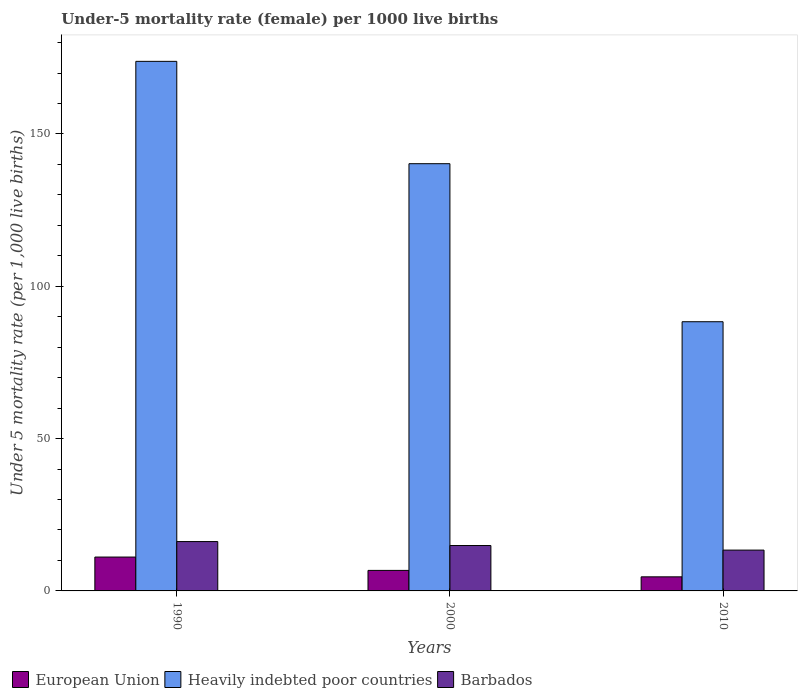How many groups of bars are there?
Your response must be concise. 3. Are the number of bars per tick equal to the number of legend labels?
Provide a short and direct response. Yes. How many bars are there on the 2nd tick from the left?
Offer a very short reply. 3. How many bars are there on the 3rd tick from the right?
Keep it short and to the point. 3. What is the label of the 1st group of bars from the left?
Offer a terse response. 1990. In how many cases, is the number of bars for a given year not equal to the number of legend labels?
Offer a terse response. 0. What is the under-five mortality rate in Barbados in 2000?
Keep it short and to the point. 14.9. Across all years, what is the minimum under-five mortality rate in Heavily indebted poor countries?
Provide a succinct answer. 88.36. In which year was the under-five mortality rate in European Union minimum?
Make the answer very short. 2010. What is the total under-five mortality rate in Heavily indebted poor countries in the graph?
Provide a short and direct response. 402.42. What is the difference between the under-five mortality rate in Barbados in 1990 and that in 2000?
Offer a terse response. 1.3. What is the difference between the under-five mortality rate in European Union in 2000 and the under-five mortality rate in Heavily indebted poor countries in 2010?
Make the answer very short. -81.63. What is the average under-five mortality rate in Heavily indebted poor countries per year?
Your response must be concise. 134.14. In the year 2010, what is the difference between the under-five mortality rate in European Union and under-five mortality rate in Heavily indebted poor countries?
Your response must be concise. -83.74. What is the ratio of the under-five mortality rate in European Union in 1990 to that in 2010?
Provide a short and direct response. 2.4. Is the under-five mortality rate in European Union in 2000 less than that in 2010?
Make the answer very short. No. Is the difference between the under-five mortality rate in European Union in 2000 and 2010 greater than the difference between the under-five mortality rate in Heavily indebted poor countries in 2000 and 2010?
Offer a terse response. No. What is the difference between the highest and the second highest under-five mortality rate in Barbados?
Ensure brevity in your answer.  1.3. What is the difference between the highest and the lowest under-five mortality rate in European Union?
Give a very brief answer. 6.49. Is the sum of the under-five mortality rate in European Union in 2000 and 2010 greater than the maximum under-five mortality rate in Barbados across all years?
Keep it short and to the point. No. What does the 2nd bar from the right in 2000 represents?
Ensure brevity in your answer.  Heavily indebted poor countries. Is it the case that in every year, the sum of the under-five mortality rate in Heavily indebted poor countries and under-five mortality rate in European Union is greater than the under-five mortality rate in Barbados?
Provide a succinct answer. Yes. What is the difference between two consecutive major ticks on the Y-axis?
Provide a succinct answer. 50. What is the title of the graph?
Your answer should be compact. Under-5 mortality rate (female) per 1000 live births. Does "Belize" appear as one of the legend labels in the graph?
Make the answer very short. No. What is the label or title of the Y-axis?
Offer a terse response. Under 5 mortality rate (per 1,0 live births). What is the Under 5 mortality rate (per 1,000 live births) in European Union in 1990?
Make the answer very short. 11.12. What is the Under 5 mortality rate (per 1,000 live births) of Heavily indebted poor countries in 1990?
Give a very brief answer. 173.83. What is the Under 5 mortality rate (per 1,000 live births) of Barbados in 1990?
Make the answer very short. 16.2. What is the Under 5 mortality rate (per 1,000 live births) of European Union in 2000?
Your response must be concise. 6.73. What is the Under 5 mortality rate (per 1,000 live births) of Heavily indebted poor countries in 2000?
Your response must be concise. 140.23. What is the Under 5 mortality rate (per 1,000 live births) in European Union in 2010?
Provide a short and direct response. 4.62. What is the Under 5 mortality rate (per 1,000 live births) of Heavily indebted poor countries in 2010?
Your answer should be compact. 88.36. Across all years, what is the maximum Under 5 mortality rate (per 1,000 live births) of European Union?
Your answer should be compact. 11.12. Across all years, what is the maximum Under 5 mortality rate (per 1,000 live births) of Heavily indebted poor countries?
Your answer should be very brief. 173.83. Across all years, what is the minimum Under 5 mortality rate (per 1,000 live births) of European Union?
Ensure brevity in your answer.  4.62. Across all years, what is the minimum Under 5 mortality rate (per 1,000 live births) in Heavily indebted poor countries?
Offer a terse response. 88.36. Across all years, what is the minimum Under 5 mortality rate (per 1,000 live births) of Barbados?
Your response must be concise. 13.4. What is the total Under 5 mortality rate (per 1,000 live births) in European Union in the graph?
Make the answer very short. 22.48. What is the total Under 5 mortality rate (per 1,000 live births) of Heavily indebted poor countries in the graph?
Your answer should be very brief. 402.42. What is the total Under 5 mortality rate (per 1,000 live births) in Barbados in the graph?
Ensure brevity in your answer.  44.5. What is the difference between the Under 5 mortality rate (per 1,000 live births) in European Union in 1990 and that in 2000?
Ensure brevity in your answer.  4.38. What is the difference between the Under 5 mortality rate (per 1,000 live births) in Heavily indebted poor countries in 1990 and that in 2000?
Offer a terse response. 33.59. What is the difference between the Under 5 mortality rate (per 1,000 live births) of European Union in 1990 and that in 2010?
Ensure brevity in your answer.  6.49. What is the difference between the Under 5 mortality rate (per 1,000 live births) of Heavily indebted poor countries in 1990 and that in 2010?
Provide a short and direct response. 85.47. What is the difference between the Under 5 mortality rate (per 1,000 live births) of Barbados in 1990 and that in 2010?
Offer a very short reply. 2.8. What is the difference between the Under 5 mortality rate (per 1,000 live births) of European Union in 2000 and that in 2010?
Ensure brevity in your answer.  2.11. What is the difference between the Under 5 mortality rate (per 1,000 live births) of Heavily indebted poor countries in 2000 and that in 2010?
Make the answer very short. 51.87. What is the difference between the Under 5 mortality rate (per 1,000 live births) of European Union in 1990 and the Under 5 mortality rate (per 1,000 live births) of Heavily indebted poor countries in 2000?
Ensure brevity in your answer.  -129.12. What is the difference between the Under 5 mortality rate (per 1,000 live births) of European Union in 1990 and the Under 5 mortality rate (per 1,000 live births) of Barbados in 2000?
Your response must be concise. -3.78. What is the difference between the Under 5 mortality rate (per 1,000 live births) of Heavily indebted poor countries in 1990 and the Under 5 mortality rate (per 1,000 live births) of Barbados in 2000?
Make the answer very short. 158.93. What is the difference between the Under 5 mortality rate (per 1,000 live births) of European Union in 1990 and the Under 5 mortality rate (per 1,000 live births) of Heavily indebted poor countries in 2010?
Ensure brevity in your answer.  -77.24. What is the difference between the Under 5 mortality rate (per 1,000 live births) in European Union in 1990 and the Under 5 mortality rate (per 1,000 live births) in Barbados in 2010?
Make the answer very short. -2.28. What is the difference between the Under 5 mortality rate (per 1,000 live births) in Heavily indebted poor countries in 1990 and the Under 5 mortality rate (per 1,000 live births) in Barbados in 2010?
Provide a succinct answer. 160.43. What is the difference between the Under 5 mortality rate (per 1,000 live births) in European Union in 2000 and the Under 5 mortality rate (per 1,000 live births) in Heavily indebted poor countries in 2010?
Give a very brief answer. -81.63. What is the difference between the Under 5 mortality rate (per 1,000 live births) in European Union in 2000 and the Under 5 mortality rate (per 1,000 live births) in Barbados in 2010?
Keep it short and to the point. -6.67. What is the difference between the Under 5 mortality rate (per 1,000 live births) of Heavily indebted poor countries in 2000 and the Under 5 mortality rate (per 1,000 live births) of Barbados in 2010?
Keep it short and to the point. 126.83. What is the average Under 5 mortality rate (per 1,000 live births) in European Union per year?
Provide a succinct answer. 7.49. What is the average Under 5 mortality rate (per 1,000 live births) of Heavily indebted poor countries per year?
Provide a short and direct response. 134.14. What is the average Under 5 mortality rate (per 1,000 live births) of Barbados per year?
Keep it short and to the point. 14.83. In the year 1990, what is the difference between the Under 5 mortality rate (per 1,000 live births) in European Union and Under 5 mortality rate (per 1,000 live births) in Heavily indebted poor countries?
Your response must be concise. -162.71. In the year 1990, what is the difference between the Under 5 mortality rate (per 1,000 live births) in European Union and Under 5 mortality rate (per 1,000 live births) in Barbados?
Offer a terse response. -5.08. In the year 1990, what is the difference between the Under 5 mortality rate (per 1,000 live births) of Heavily indebted poor countries and Under 5 mortality rate (per 1,000 live births) of Barbados?
Offer a very short reply. 157.63. In the year 2000, what is the difference between the Under 5 mortality rate (per 1,000 live births) of European Union and Under 5 mortality rate (per 1,000 live births) of Heavily indebted poor countries?
Your answer should be very brief. -133.5. In the year 2000, what is the difference between the Under 5 mortality rate (per 1,000 live births) in European Union and Under 5 mortality rate (per 1,000 live births) in Barbados?
Keep it short and to the point. -8.17. In the year 2000, what is the difference between the Under 5 mortality rate (per 1,000 live births) in Heavily indebted poor countries and Under 5 mortality rate (per 1,000 live births) in Barbados?
Ensure brevity in your answer.  125.33. In the year 2010, what is the difference between the Under 5 mortality rate (per 1,000 live births) of European Union and Under 5 mortality rate (per 1,000 live births) of Heavily indebted poor countries?
Your answer should be compact. -83.74. In the year 2010, what is the difference between the Under 5 mortality rate (per 1,000 live births) of European Union and Under 5 mortality rate (per 1,000 live births) of Barbados?
Provide a short and direct response. -8.78. In the year 2010, what is the difference between the Under 5 mortality rate (per 1,000 live births) in Heavily indebted poor countries and Under 5 mortality rate (per 1,000 live births) in Barbados?
Your answer should be compact. 74.96. What is the ratio of the Under 5 mortality rate (per 1,000 live births) in European Union in 1990 to that in 2000?
Give a very brief answer. 1.65. What is the ratio of the Under 5 mortality rate (per 1,000 live births) of Heavily indebted poor countries in 1990 to that in 2000?
Your answer should be compact. 1.24. What is the ratio of the Under 5 mortality rate (per 1,000 live births) of Barbados in 1990 to that in 2000?
Offer a very short reply. 1.09. What is the ratio of the Under 5 mortality rate (per 1,000 live births) in European Union in 1990 to that in 2010?
Provide a succinct answer. 2.4. What is the ratio of the Under 5 mortality rate (per 1,000 live births) in Heavily indebted poor countries in 1990 to that in 2010?
Give a very brief answer. 1.97. What is the ratio of the Under 5 mortality rate (per 1,000 live births) of Barbados in 1990 to that in 2010?
Give a very brief answer. 1.21. What is the ratio of the Under 5 mortality rate (per 1,000 live births) in European Union in 2000 to that in 2010?
Your response must be concise. 1.46. What is the ratio of the Under 5 mortality rate (per 1,000 live births) in Heavily indebted poor countries in 2000 to that in 2010?
Ensure brevity in your answer.  1.59. What is the ratio of the Under 5 mortality rate (per 1,000 live births) in Barbados in 2000 to that in 2010?
Your answer should be very brief. 1.11. What is the difference between the highest and the second highest Under 5 mortality rate (per 1,000 live births) in European Union?
Offer a terse response. 4.38. What is the difference between the highest and the second highest Under 5 mortality rate (per 1,000 live births) of Heavily indebted poor countries?
Ensure brevity in your answer.  33.59. What is the difference between the highest and the lowest Under 5 mortality rate (per 1,000 live births) of European Union?
Give a very brief answer. 6.49. What is the difference between the highest and the lowest Under 5 mortality rate (per 1,000 live births) in Heavily indebted poor countries?
Make the answer very short. 85.47. What is the difference between the highest and the lowest Under 5 mortality rate (per 1,000 live births) in Barbados?
Your response must be concise. 2.8. 